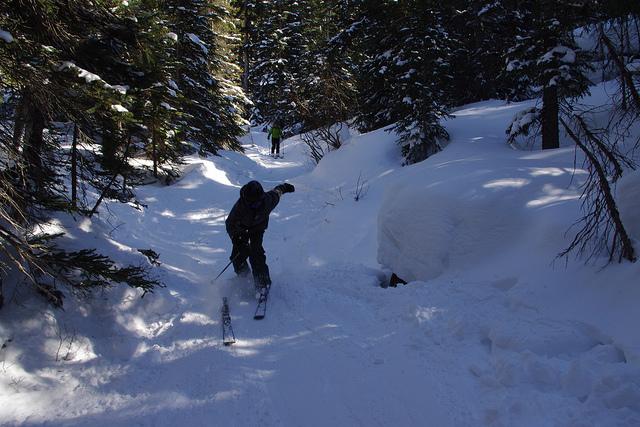What is the man doing?
Quick response, please. Skiing. Is the man practicing for an official tournament?
Keep it brief. Yes. Is it sunny outside?
Quick response, please. Yes. Was this picture taken at the ocean?
Concise answer only. No. What style of skiing are they doing?
Give a very brief answer. Downhill. 